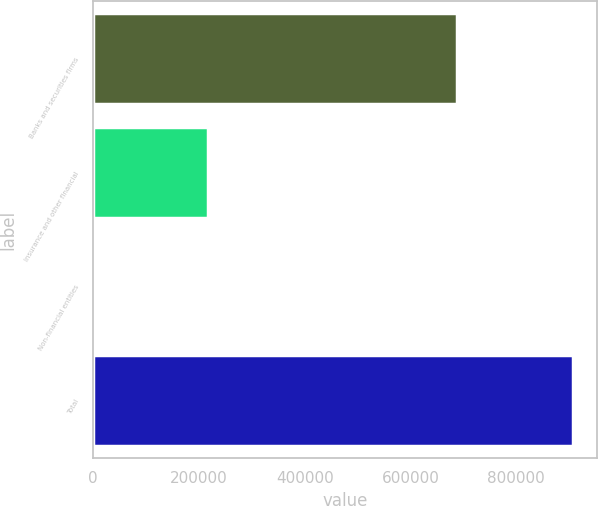<chart> <loc_0><loc_0><loc_500><loc_500><bar_chart><fcel>Banks and securities firms<fcel>Insurance and other financial<fcel>Non-financial entities<fcel>Total<nl><fcel>687155<fcel>217201<fcel>3706<fcel>908062<nl></chart> 